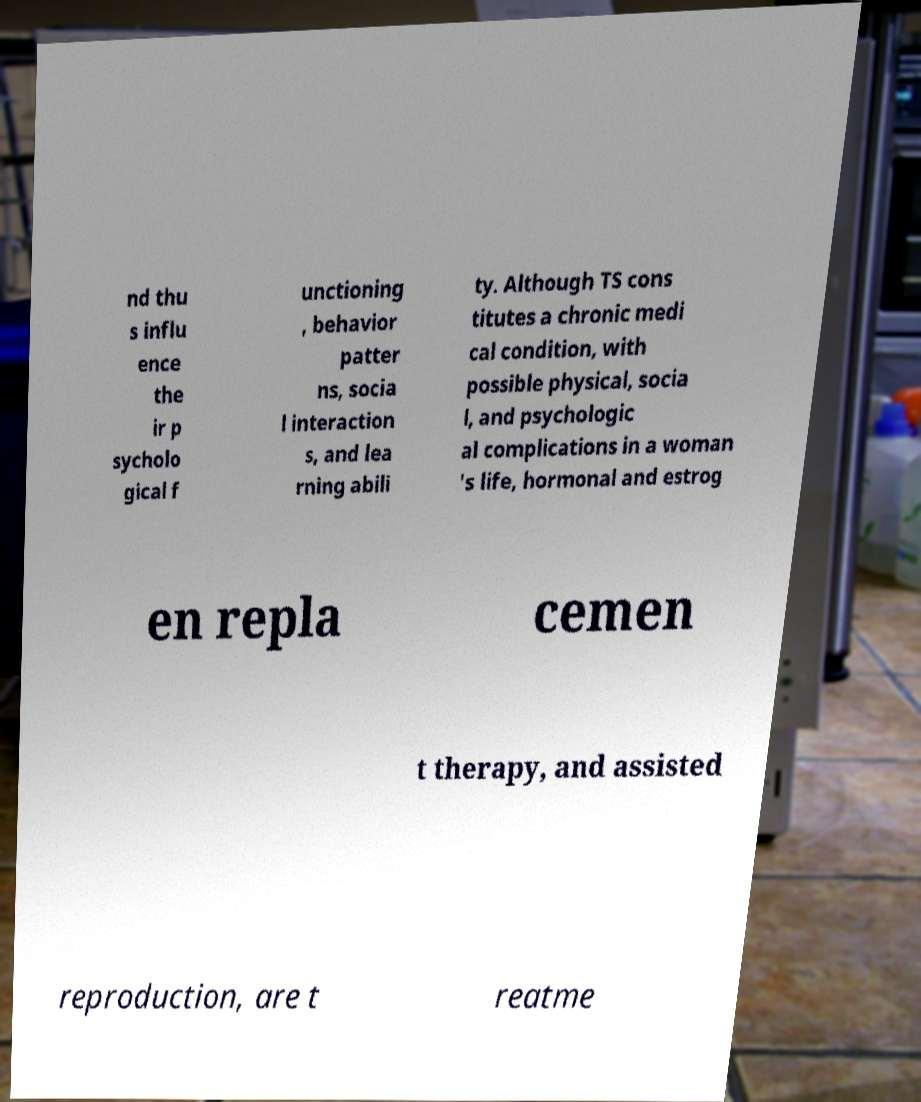Can you accurately transcribe the text from the provided image for me? nd thu s influ ence the ir p sycholo gical f unctioning , behavior patter ns, socia l interaction s, and lea rning abili ty. Although TS cons titutes a chronic medi cal condition, with possible physical, socia l, and psychologic al complications in a woman 's life, hormonal and estrog en repla cemen t therapy, and assisted reproduction, are t reatme 